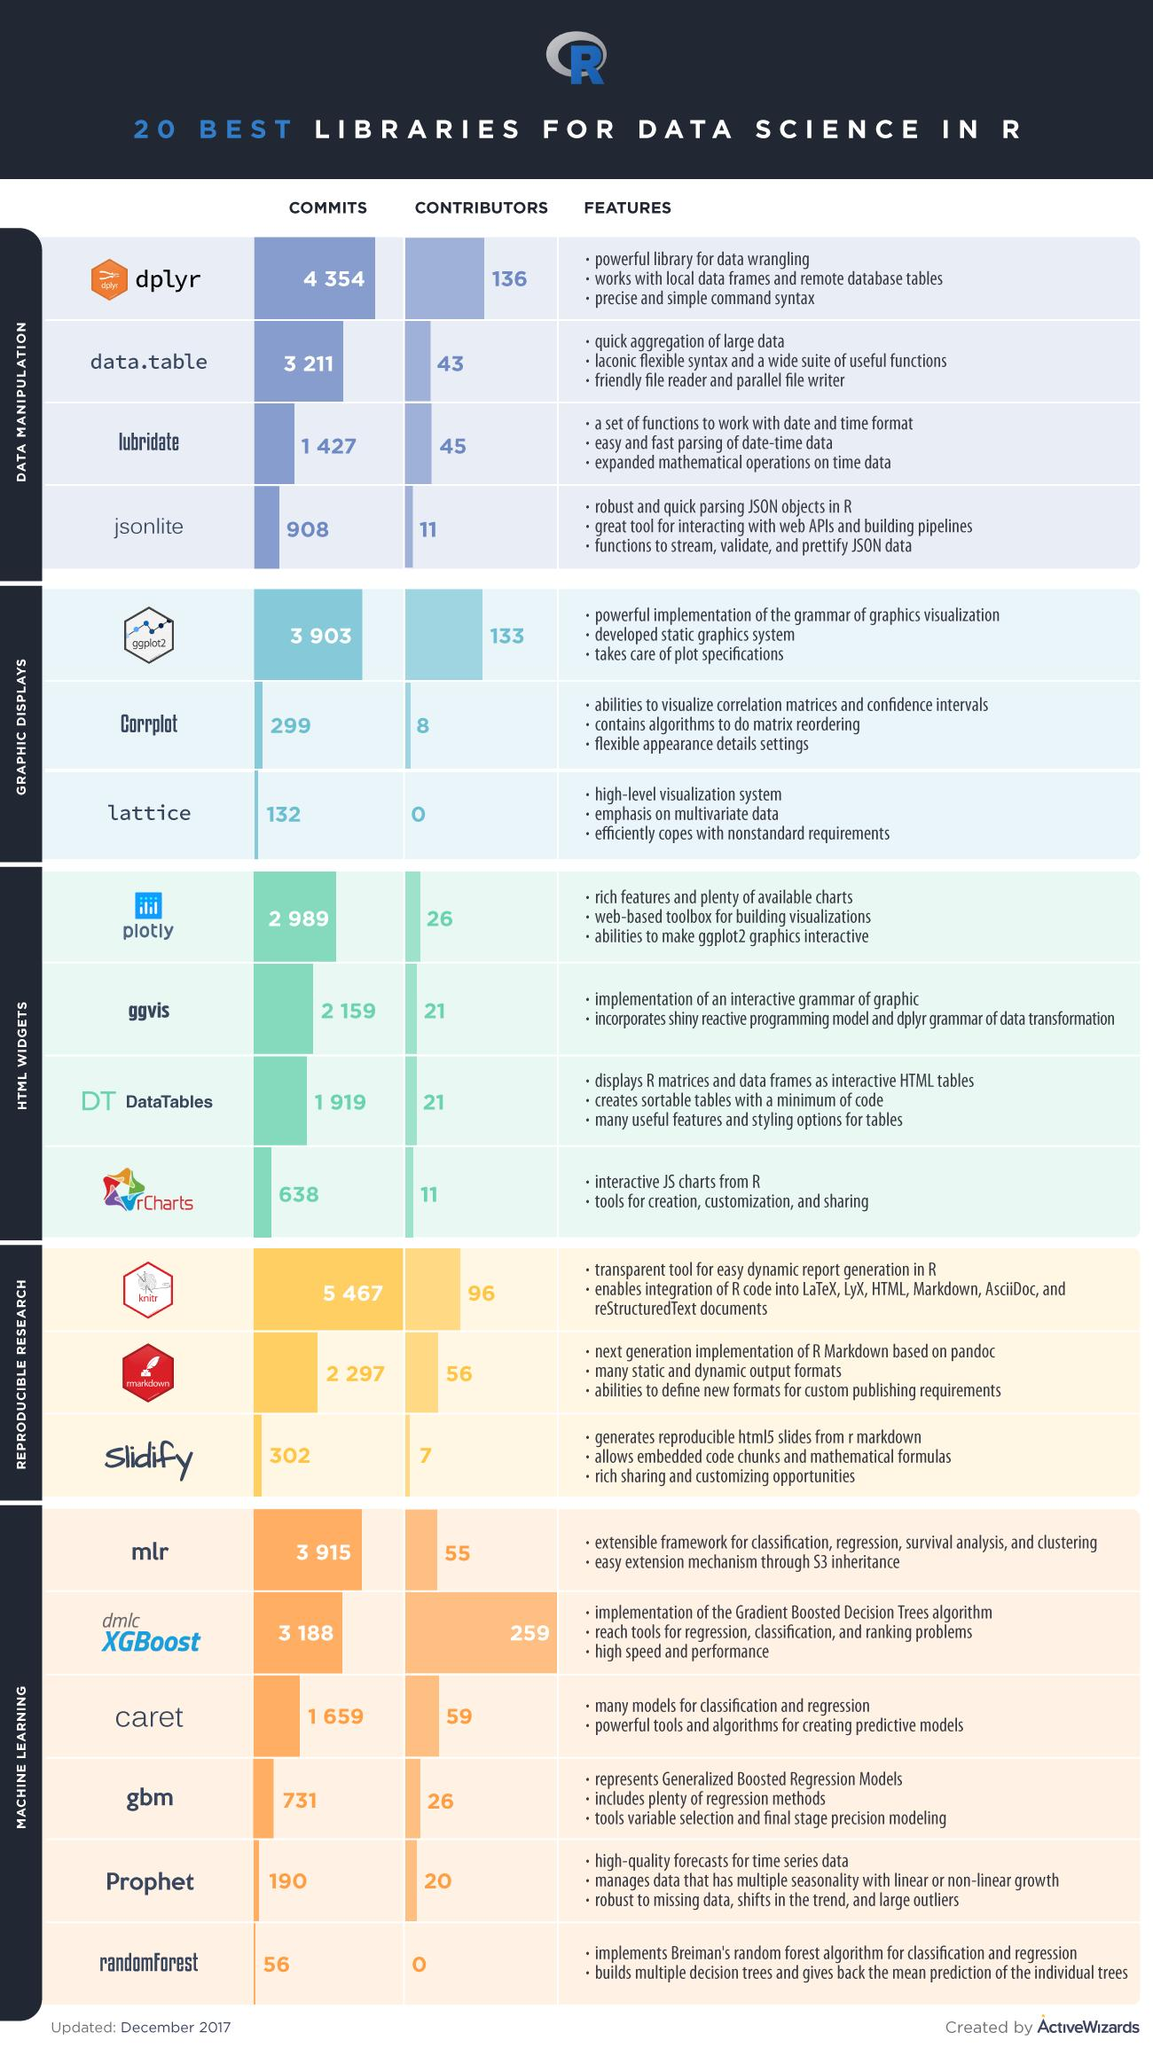Mention a couple of crucial points in this snapshot. There are six libraries for machine learning. There are three points under the heading features of dplyr. The number of contributors to both the dplyr and jsonlite packages is 147. There are three libraries available for graphic displays. There are 4 libraries available for HTML widgets. 